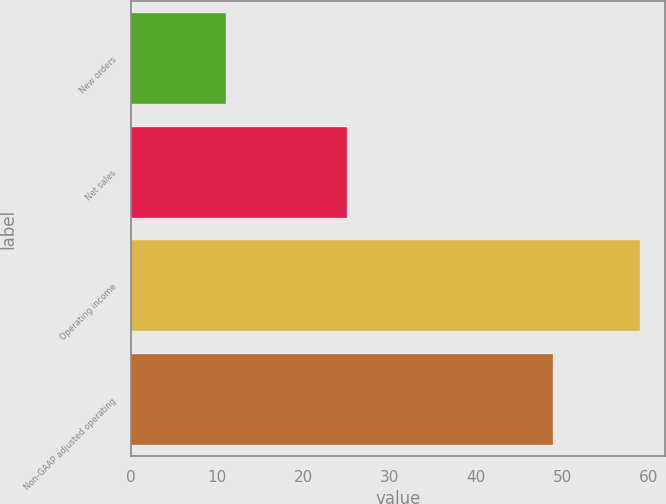Convert chart. <chart><loc_0><loc_0><loc_500><loc_500><bar_chart><fcel>New orders<fcel>Net sales<fcel>Operating income<fcel>Non-GAAP adjusted operating<nl><fcel>11<fcel>25<fcel>59<fcel>49<nl></chart> 